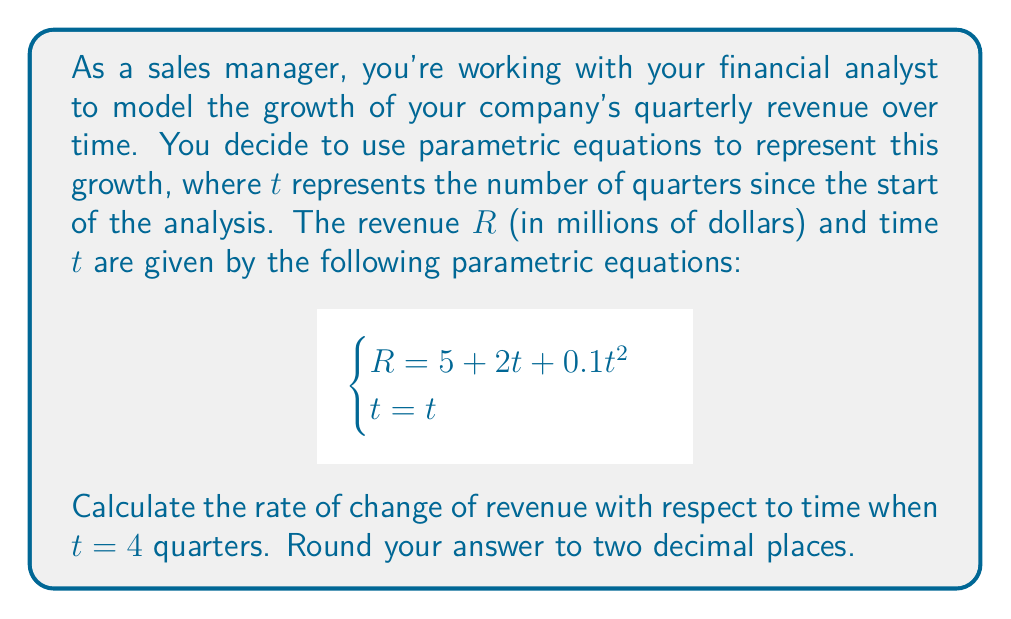Could you help me with this problem? To solve this problem, we need to follow these steps:

1) The rate of change of revenue with respect to time is given by $\frac{dR}{dt}$.

2) To find $\frac{dR}{dt}$, we need to use the chain rule:

   $$\frac{dR}{dt} = \frac{dR}{dt} \cdot \frac{dt}{dt}$$

3) First, let's find $\frac{dR}{dt}$:
   
   $$\frac{dR}{dt} = 2 + 0.2t$$

4) Now, $\frac{dt}{dt} = 1$ (since $t = t$)

5) Therefore, 
   
   $$\frac{dR}{dt} = (2 + 0.2t) \cdot 1 = 2 + 0.2t$$

6) We need to evaluate this at $t = 4$:

   $$\frac{dR}{dt}\Big|_{t=4} = 2 + 0.2(4) = 2 + 0.8 = 2.8$$

7) Rounding to two decimal places, we get 2.80.

This means that after 4 quarters, the revenue is increasing at a rate of 2.80 million dollars per quarter.
Answer: $2.80$ million dollars per quarter 